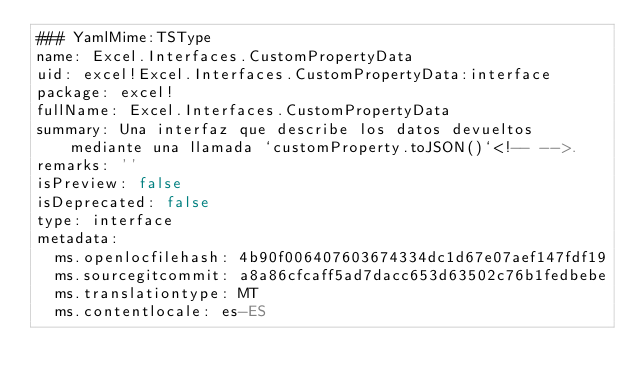<code> <loc_0><loc_0><loc_500><loc_500><_YAML_>### YamlMime:TSType
name: Excel.Interfaces.CustomPropertyData
uid: excel!Excel.Interfaces.CustomPropertyData:interface
package: excel!
fullName: Excel.Interfaces.CustomPropertyData
summary: Una interfaz que describe los datos devueltos mediante una llamada `customProperty.toJSON()`<!-- -->.
remarks: ''
isPreview: false
isDeprecated: false
type: interface
metadata:
  ms.openlocfilehash: 4b90f006407603674334dc1d67e07aef147fdf19
  ms.sourcegitcommit: a8a86cfcaff5ad7dacc653d63502c76b1fedbebe
  ms.translationtype: MT
  ms.contentlocale: es-ES</code> 